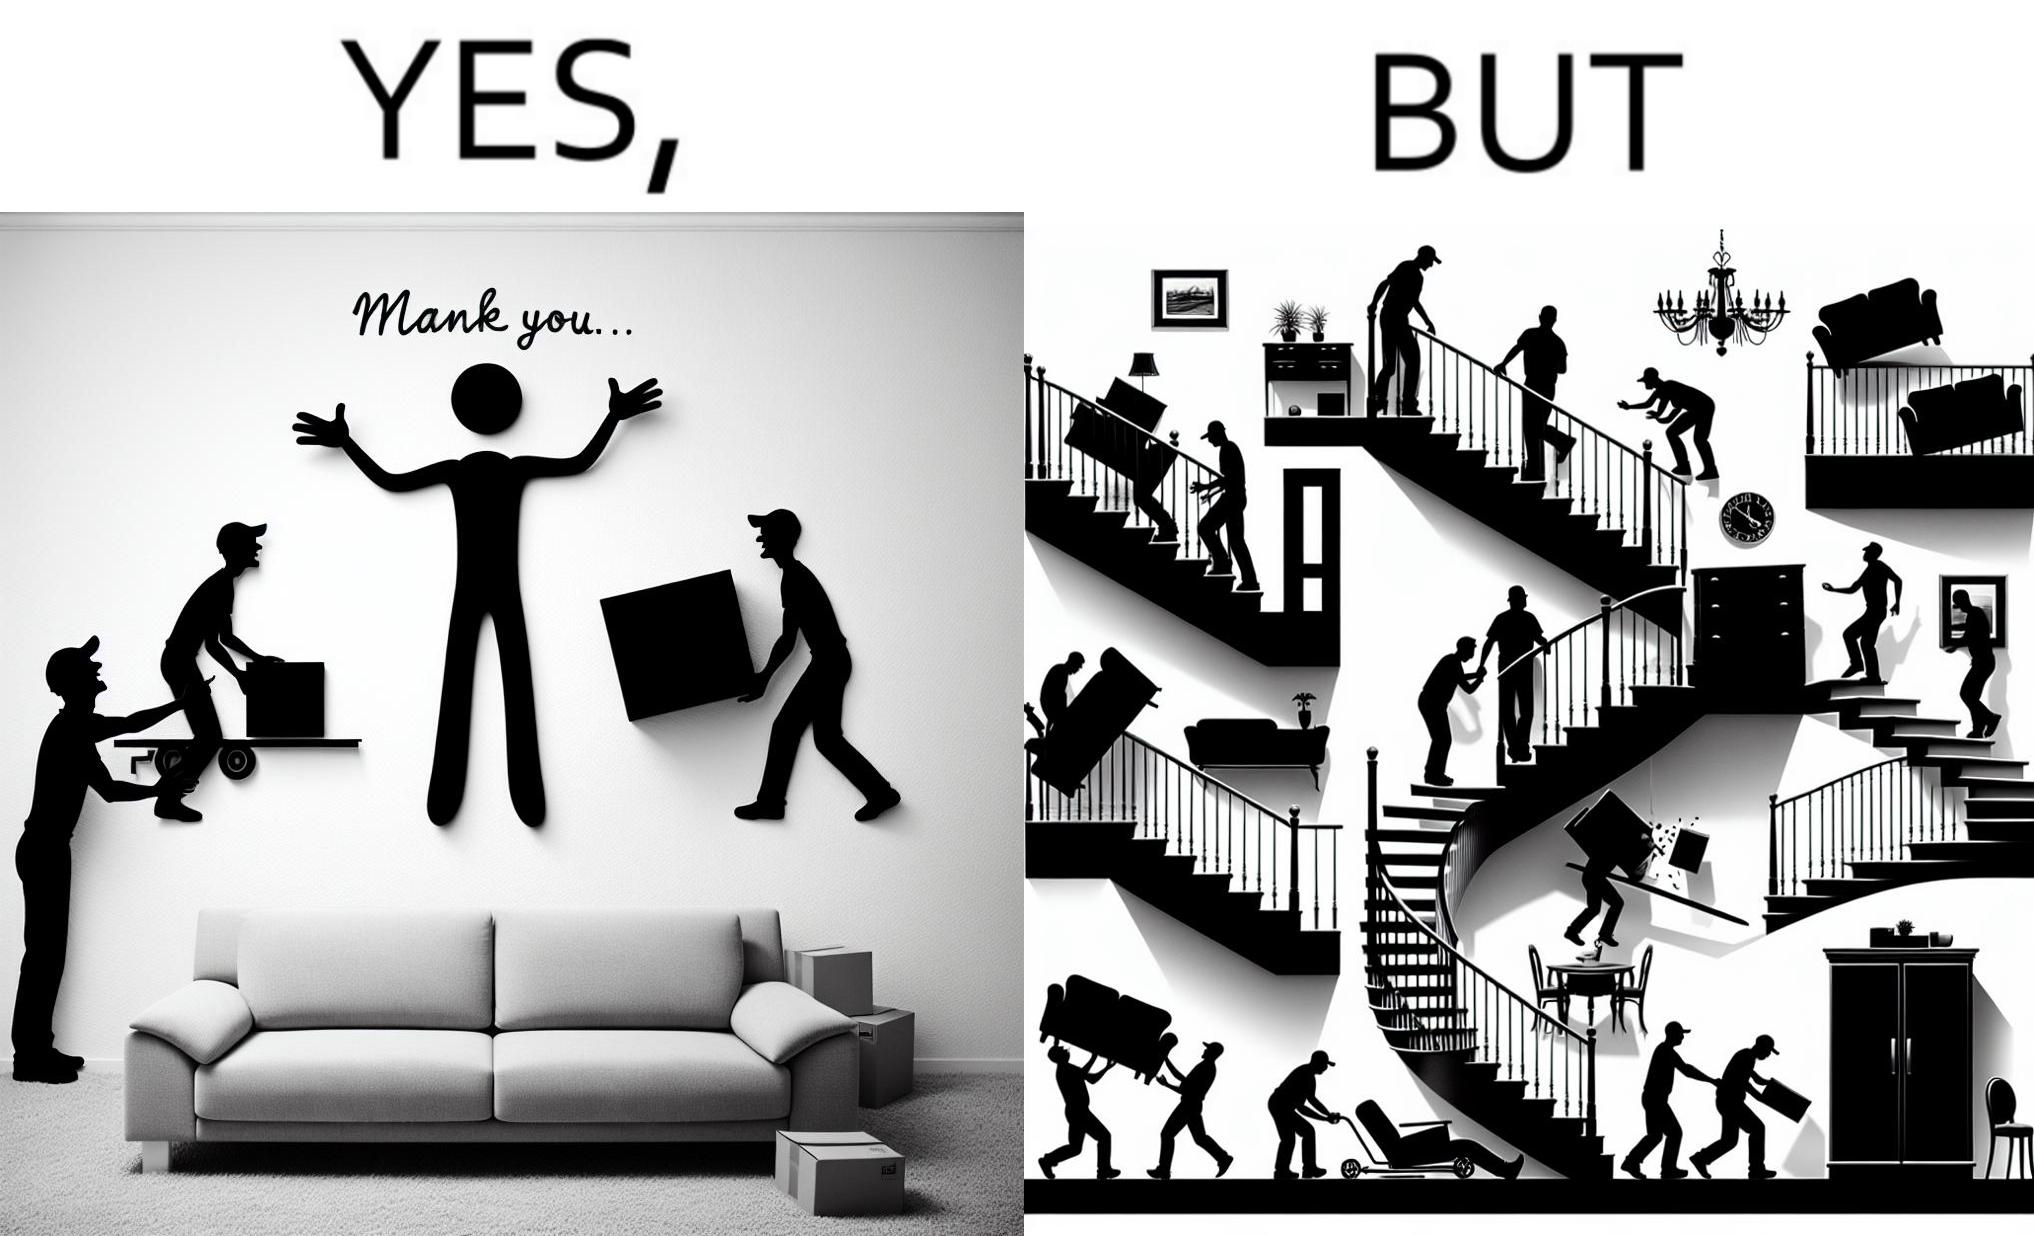Would you classify this image as satirical? Yes, this image is satirical. 